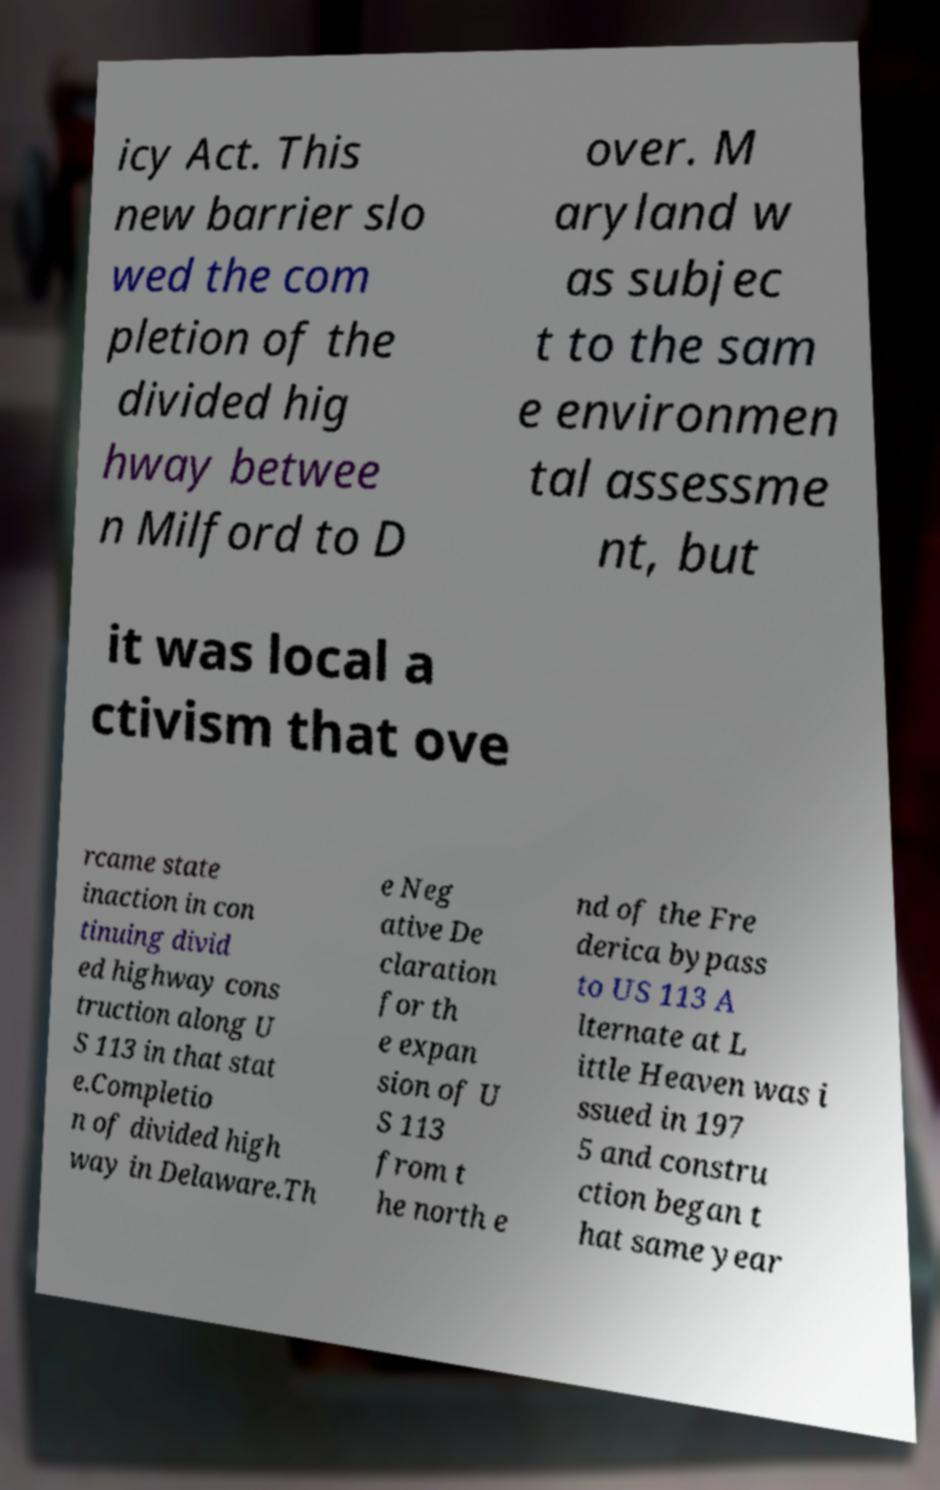Please identify and transcribe the text found in this image. icy Act. This new barrier slo wed the com pletion of the divided hig hway betwee n Milford to D over. M aryland w as subjec t to the sam e environmen tal assessme nt, but it was local a ctivism that ove rcame state inaction in con tinuing divid ed highway cons truction along U S 113 in that stat e.Completio n of divided high way in Delaware.Th e Neg ative De claration for th e expan sion of U S 113 from t he north e nd of the Fre derica bypass to US 113 A lternate at L ittle Heaven was i ssued in 197 5 and constru ction began t hat same year 